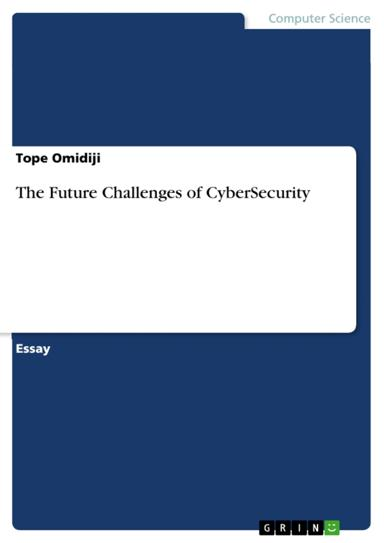Can you provide a summary of the main topics likely covered based on the essay's title? Based on the title "The Future Challenges of CyberSecurity", the essay likely explores emerging threats in the digital space, such as advanced persistent threats (APTs), the implications of artificial intelligence in security, the increasing complexity of cybersecurity with the Internet of Things (IoT), and strategies for proactive defense mechanisms. 